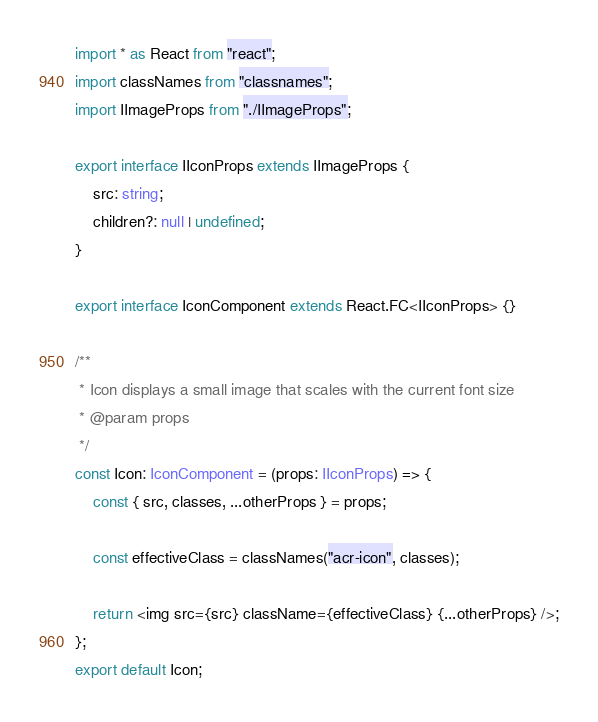Convert code to text. <code><loc_0><loc_0><loc_500><loc_500><_TypeScript_>import * as React from "react";
import classNames from "classnames";
import IImageProps from "./IImageProps";

export interface IIconProps extends IImageProps {
	src: string;
	children?: null | undefined;
}

export interface IconComponent extends React.FC<IIconProps> {}

/**
 * Icon displays a small image that scales with the current font size
 * @param props
 */
const Icon: IconComponent = (props: IIconProps) => {
	const { src, classes, ...otherProps } = props;

	const effectiveClass = classNames("acr-icon", classes);

	return <img src={src} className={effectiveClass} {...otherProps} />;
};
export default Icon;
</code> 